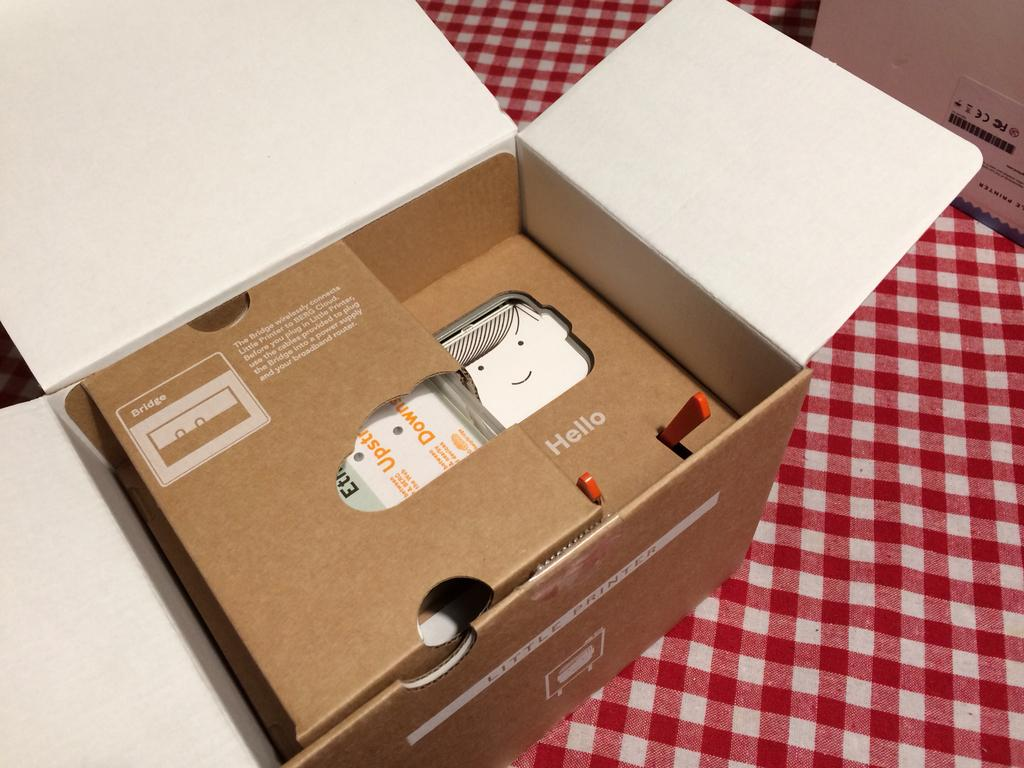<image>
Share a concise interpretation of the image provided. A cardboard box from Little Printer is open to show its contents. 